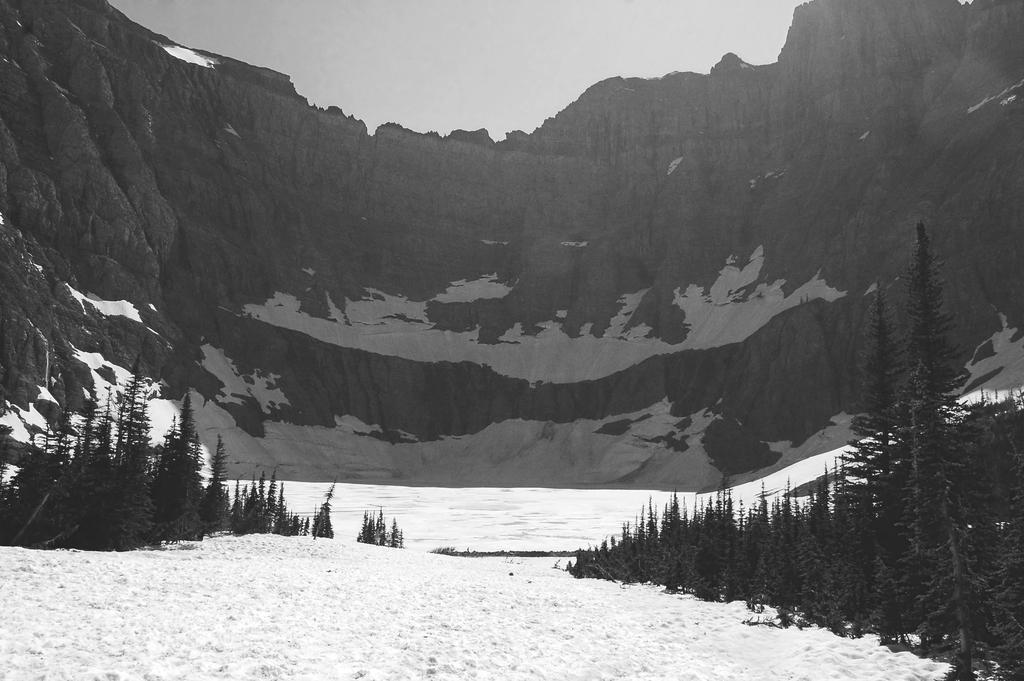Please provide a concise description of this image. In this picture I can see there is snow and there are plants, trees and the sky is clear. 